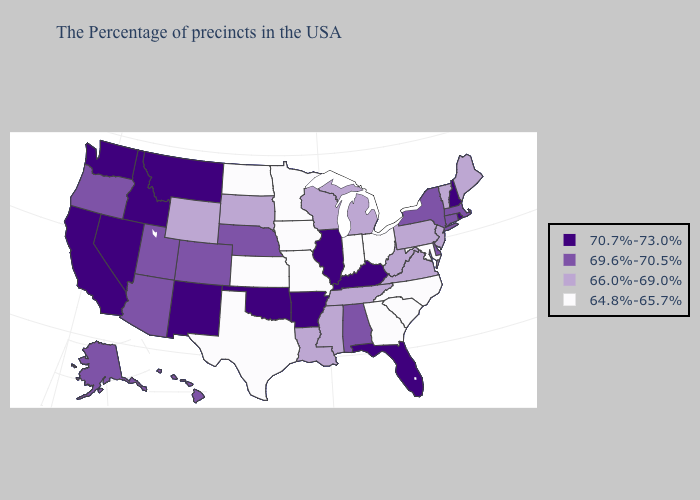Does Arizona have a lower value than Nevada?
Be succinct. Yes. Among the states that border California , does Oregon have the highest value?
Answer briefly. No. What is the lowest value in the MidWest?
Short answer required. 64.8%-65.7%. What is the highest value in states that border Missouri?
Short answer required. 70.7%-73.0%. What is the value of Arkansas?
Answer briefly. 70.7%-73.0%. Name the states that have a value in the range 69.6%-70.5%?
Write a very short answer. Massachusetts, Connecticut, New York, Delaware, Alabama, Nebraska, Colorado, Utah, Arizona, Oregon, Alaska, Hawaii. Which states have the highest value in the USA?
Be succinct. Rhode Island, New Hampshire, Florida, Kentucky, Illinois, Arkansas, Oklahoma, New Mexico, Montana, Idaho, Nevada, California, Washington. What is the value of South Dakota?
Quick response, please. 66.0%-69.0%. Among the states that border West Virginia , does Pennsylvania have the highest value?
Be succinct. No. Does Michigan have a higher value than Missouri?
Concise answer only. Yes. Which states have the lowest value in the South?
Concise answer only. Maryland, North Carolina, South Carolina, Georgia, Texas. What is the value of New York?
Quick response, please. 69.6%-70.5%. Does Florida have the same value as Pennsylvania?
Concise answer only. No. What is the value of Alaska?
Be succinct. 69.6%-70.5%. 